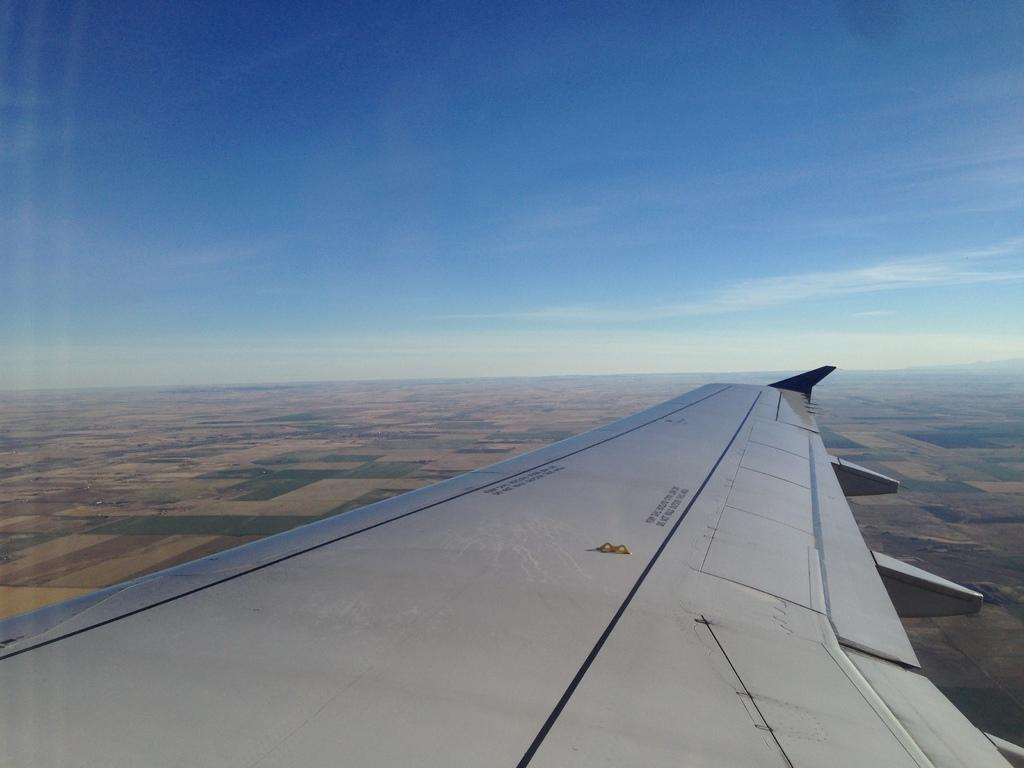What is the main subject of the picture? The main subject of the picture is an airplane. What can be seen at the top of the image? The sky is visible at the top of the image. What is the condition of the sky in the picture? There are clouds in the sky. What type of vegetation is present at the bottom of the image? Grass is present at the bottom of the image. What type of landscape can be seen in the image? There are fields in the image. How many fish can be seen swimming in the airplane in the image? There are no fish present in the image, and the airplane is not a body of water where fish could swim. 